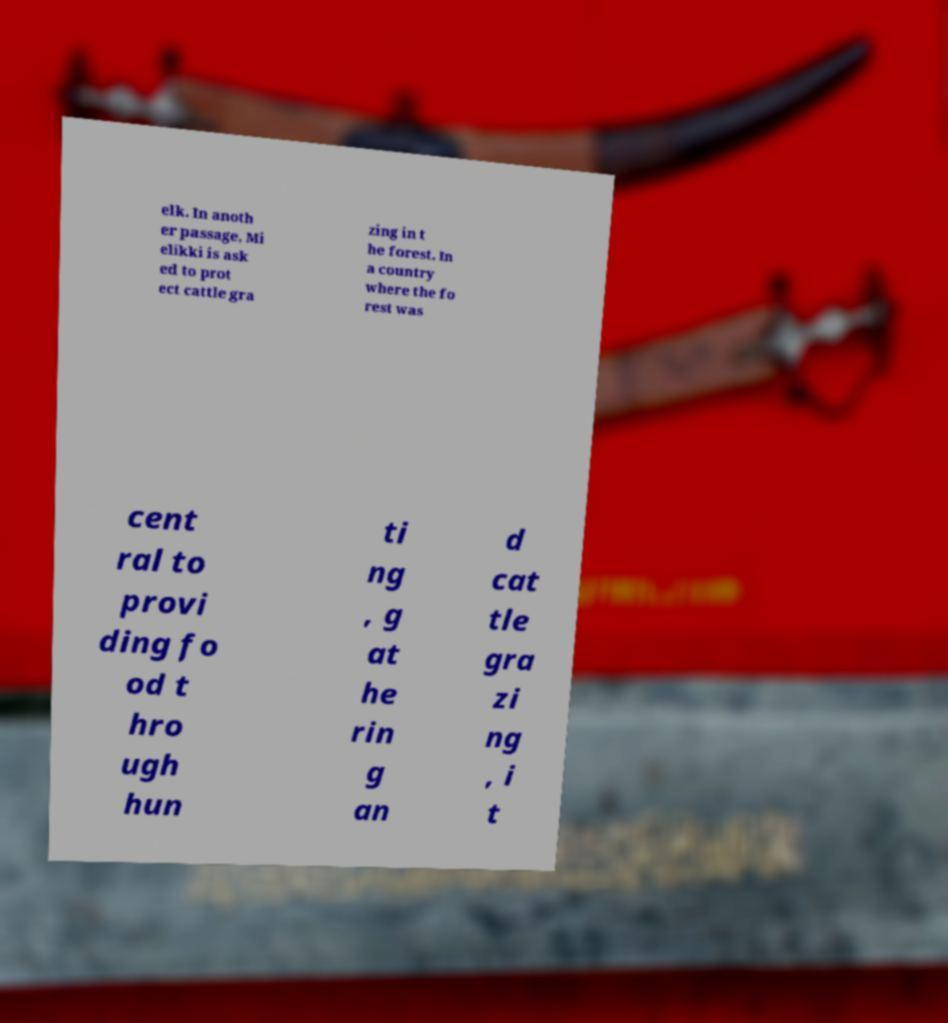Can you read and provide the text displayed in the image?This photo seems to have some interesting text. Can you extract and type it out for me? elk. In anoth er passage, Mi elikki is ask ed to prot ect cattle gra zing in t he forest. In a country where the fo rest was cent ral to provi ding fo od t hro ugh hun ti ng , g at he rin g an d cat tle gra zi ng , i t 